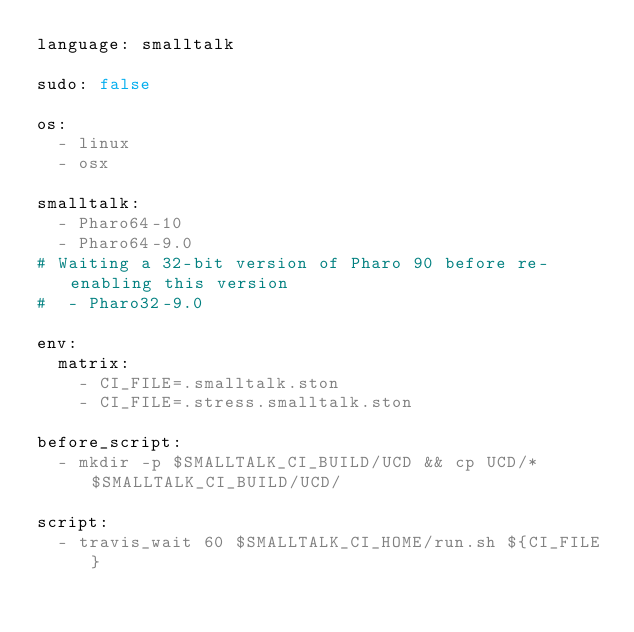Convert code to text. <code><loc_0><loc_0><loc_500><loc_500><_YAML_>language: smalltalk

sudo: false

os:
  - linux
  - osx
  
smalltalk:
  - Pharo64-10
  - Pharo64-9.0
# Waiting a 32-bit version of Pharo 90 before re-enabling this version
#  - Pharo32-9.0

env:
  matrix:
    - CI_FILE=.smalltalk.ston
    - CI_FILE=.stress.smalltalk.ston

before_script:
  - mkdir -p $SMALLTALK_CI_BUILD/UCD && cp UCD/* $SMALLTALK_CI_BUILD/UCD/

script:
  - travis_wait 60 $SMALLTALK_CI_HOME/run.sh ${CI_FILE}
</code> 